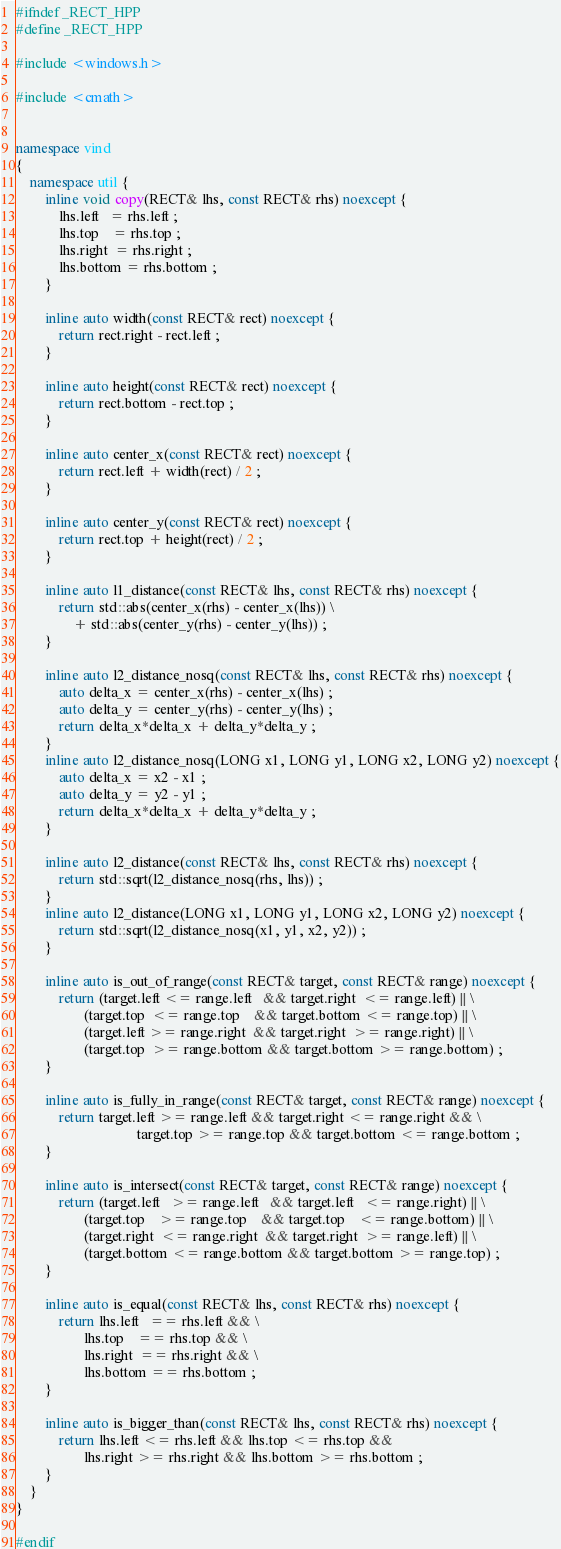Convert code to text. <code><loc_0><loc_0><loc_500><loc_500><_C++_>#ifndef _RECT_HPP
#define _RECT_HPP

#include <windows.h>

#include <cmath>


namespace vind
{
    namespace util {
        inline void copy(RECT& lhs, const RECT& rhs) noexcept {
            lhs.left   = rhs.left ;
            lhs.top    = rhs.top ;
            lhs.right  = rhs.right ;
            lhs.bottom = rhs.bottom ;
        }

        inline auto width(const RECT& rect) noexcept {
            return rect.right - rect.left ;
        }

        inline auto height(const RECT& rect) noexcept {
            return rect.bottom - rect.top ;
        }

        inline auto center_x(const RECT& rect) noexcept {
            return rect.left + width(rect) / 2 ;
        }

        inline auto center_y(const RECT& rect) noexcept {
            return rect.top + height(rect) / 2 ;
        }

        inline auto l1_distance(const RECT& lhs, const RECT& rhs) noexcept {
            return std::abs(center_x(rhs) - center_x(lhs)) \
                + std::abs(center_y(rhs) - center_y(lhs)) ;
        }

        inline auto l2_distance_nosq(const RECT& lhs, const RECT& rhs) noexcept {
            auto delta_x = center_x(rhs) - center_x(lhs) ;
            auto delta_y = center_y(rhs) - center_y(lhs) ;
            return delta_x*delta_x + delta_y*delta_y ;
        }
        inline auto l2_distance_nosq(LONG x1, LONG y1, LONG x2, LONG y2) noexcept {
            auto delta_x = x2 - x1 ;
            auto delta_y = y2 - y1 ;
            return delta_x*delta_x + delta_y*delta_y ;
        }

        inline auto l2_distance(const RECT& lhs, const RECT& rhs) noexcept {
            return std::sqrt(l2_distance_nosq(rhs, lhs)) ;
        }
        inline auto l2_distance(LONG x1, LONG y1, LONG x2, LONG y2) noexcept {
            return std::sqrt(l2_distance_nosq(x1, y1, x2, y2)) ;
        }

        inline auto is_out_of_range(const RECT& target, const RECT& range) noexcept {
            return (target.left <= range.left   && target.right  <= range.left) || \
                   (target.top  <= range.top    && target.bottom <= range.top) || \
                   (target.left >= range.right  && target.right  >= range.right) || \
                   (target.top  >= range.bottom && target.bottom >= range.bottom) ;
        }

        inline auto is_fully_in_range(const RECT& target, const RECT& range) noexcept {
            return target.left >= range.left && target.right <= range.right && \
                                  target.top >= range.top && target.bottom <= range.bottom ;
        }

        inline auto is_intersect(const RECT& target, const RECT& range) noexcept {
            return (target.left   >= range.left   && target.left   <= range.right) || \
                   (target.top    >= range.top    && target.top    <= range.bottom) || \
                   (target.right  <= range.right  && target.right  >= range.left) || \
                   (target.bottom <= range.bottom && target.bottom >= range.top) ;
        }

        inline auto is_equal(const RECT& lhs, const RECT& rhs) noexcept {
            return lhs.left   == rhs.left && \
                   lhs.top    == rhs.top && \
                   lhs.right  == rhs.right && \
                   lhs.bottom == rhs.bottom ;
        }

        inline auto is_bigger_than(const RECT& lhs, const RECT& rhs) noexcept {
            return lhs.left <= rhs.left && lhs.top <= rhs.top &&
                   lhs.right >= rhs.right && lhs.bottom >= rhs.bottom ;
        }
    }
}

#endif
</code> 